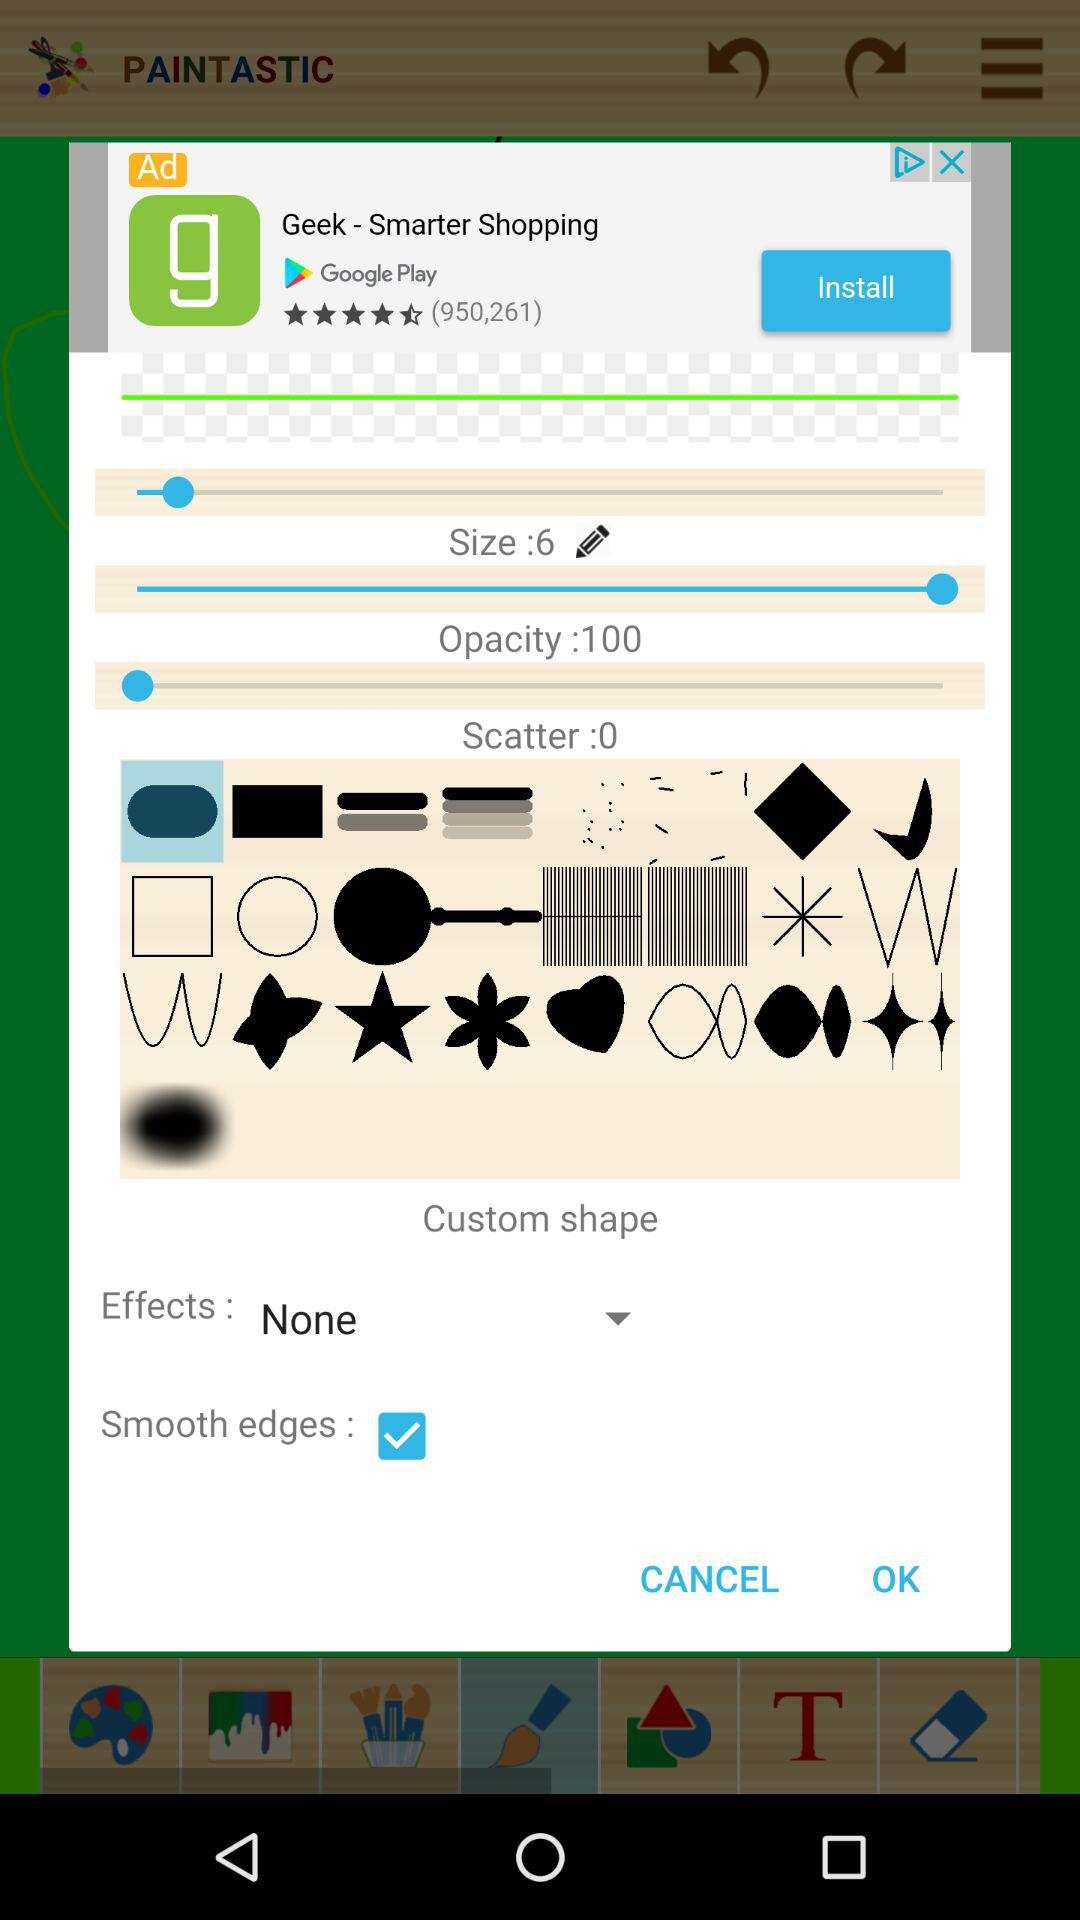What is the scatter? The scatter is 0. 